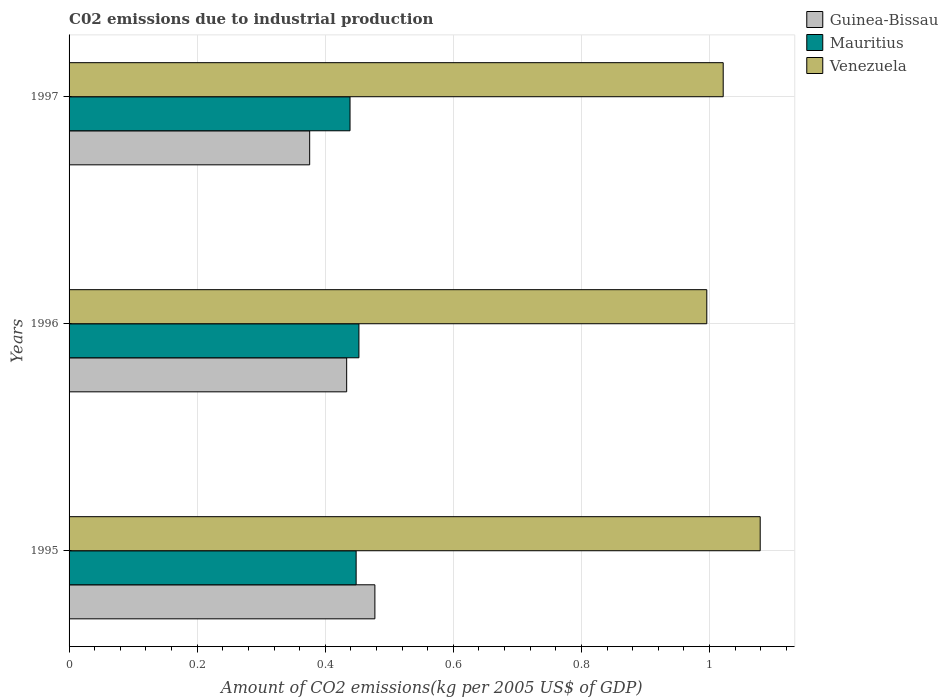Are the number of bars per tick equal to the number of legend labels?
Give a very brief answer. Yes. Are the number of bars on each tick of the Y-axis equal?
Your response must be concise. Yes. How many bars are there on the 2nd tick from the top?
Provide a short and direct response. 3. What is the label of the 1st group of bars from the top?
Ensure brevity in your answer.  1997. What is the amount of CO2 emitted due to industrial production in Venezuela in 1995?
Provide a short and direct response. 1.08. Across all years, what is the maximum amount of CO2 emitted due to industrial production in Guinea-Bissau?
Provide a succinct answer. 0.48. Across all years, what is the minimum amount of CO2 emitted due to industrial production in Venezuela?
Ensure brevity in your answer.  1. In which year was the amount of CO2 emitted due to industrial production in Guinea-Bissau minimum?
Provide a succinct answer. 1997. What is the total amount of CO2 emitted due to industrial production in Mauritius in the graph?
Provide a short and direct response. 1.34. What is the difference between the amount of CO2 emitted due to industrial production in Mauritius in 1996 and that in 1997?
Offer a very short reply. 0.01. What is the difference between the amount of CO2 emitted due to industrial production in Mauritius in 1997 and the amount of CO2 emitted due to industrial production in Guinea-Bissau in 1995?
Ensure brevity in your answer.  -0.04. What is the average amount of CO2 emitted due to industrial production in Venezuela per year?
Offer a very short reply. 1.03. In the year 1996, what is the difference between the amount of CO2 emitted due to industrial production in Guinea-Bissau and amount of CO2 emitted due to industrial production in Mauritius?
Offer a very short reply. -0.02. In how many years, is the amount of CO2 emitted due to industrial production in Guinea-Bissau greater than 0.7200000000000001 kg?
Provide a succinct answer. 0. What is the ratio of the amount of CO2 emitted due to industrial production in Venezuela in 1995 to that in 1996?
Your answer should be compact. 1.08. Is the amount of CO2 emitted due to industrial production in Venezuela in 1995 less than that in 1997?
Offer a terse response. No. What is the difference between the highest and the second highest amount of CO2 emitted due to industrial production in Mauritius?
Offer a very short reply. 0. What is the difference between the highest and the lowest amount of CO2 emitted due to industrial production in Mauritius?
Provide a short and direct response. 0.01. Is the sum of the amount of CO2 emitted due to industrial production in Venezuela in 1995 and 1997 greater than the maximum amount of CO2 emitted due to industrial production in Guinea-Bissau across all years?
Keep it short and to the point. Yes. What does the 1st bar from the top in 1995 represents?
Provide a short and direct response. Venezuela. What does the 1st bar from the bottom in 1997 represents?
Give a very brief answer. Guinea-Bissau. Is it the case that in every year, the sum of the amount of CO2 emitted due to industrial production in Guinea-Bissau and amount of CO2 emitted due to industrial production in Mauritius is greater than the amount of CO2 emitted due to industrial production in Venezuela?
Provide a succinct answer. No. Are all the bars in the graph horizontal?
Provide a short and direct response. Yes. How many years are there in the graph?
Ensure brevity in your answer.  3. What is the difference between two consecutive major ticks on the X-axis?
Give a very brief answer. 0.2. Are the values on the major ticks of X-axis written in scientific E-notation?
Offer a very short reply. No. Does the graph contain any zero values?
Your answer should be very brief. No. Does the graph contain grids?
Your response must be concise. Yes. Where does the legend appear in the graph?
Keep it short and to the point. Top right. How many legend labels are there?
Keep it short and to the point. 3. How are the legend labels stacked?
Make the answer very short. Vertical. What is the title of the graph?
Your answer should be compact. C02 emissions due to industrial production. What is the label or title of the X-axis?
Your response must be concise. Amount of CO2 emissions(kg per 2005 US$ of GDP). What is the Amount of CO2 emissions(kg per 2005 US$ of GDP) in Guinea-Bissau in 1995?
Your answer should be compact. 0.48. What is the Amount of CO2 emissions(kg per 2005 US$ of GDP) of Mauritius in 1995?
Provide a short and direct response. 0.45. What is the Amount of CO2 emissions(kg per 2005 US$ of GDP) in Venezuela in 1995?
Your response must be concise. 1.08. What is the Amount of CO2 emissions(kg per 2005 US$ of GDP) of Guinea-Bissau in 1996?
Your answer should be compact. 0.43. What is the Amount of CO2 emissions(kg per 2005 US$ of GDP) of Mauritius in 1996?
Provide a short and direct response. 0.45. What is the Amount of CO2 emissions(kg per 2005 US$ of GDP) in Venezuela in 1996?
Your response must be concise. 1. What is the Amount of CO2 emissions(kg per 2005 US$ of GDP) of Guinea-Bissau in 1997?
Keep it short and to the point. 0.38. What is the Amount of CO2 emissions(kg per 2005 US$ of GDP) of Mauritius in 1997?
Keep it short and to the point. 0.44. What is the Amount of CO2 emissions(kg per 2005 US$ of GDP) of Venezuela in 1997?
Provide a short and direct response. 1.02. Across all years, what is the maximum Amount of CO2 emissions(kg per 2005 US$ of GDP) in Guinea-Bissau?
Provide a short and direct response. 0.48. Across all years, what is the maximum Amount of CO2 emissions(kg per 2005 US$ of GDP) of Mauritius?
Give a very brief answer. 0.45. Across all years, what is the maximum Amount of CO2 emissions(kg per 2005 US$ of GDP) in Venezuela?
Provide a succinct answer. 1.08. Across all years, what is the minimum Amount of CO2 emissions(kg per 2005 US$ of GDP) of Guinea-Bissau?
Provide a short and direct response. 0.38. Across all years, what is the minimum Amount of CO2 emissions(kg per 2005 US$ of GDP) in Mauritius?
Offer a very short reply. 0.44. Across all years, what is the minimum Amount of CO2 emissions(kg per 2005 US$ of GDP) in Venezuela?
Ensure brevity in your answer.  1. What is the total Amount of CO2 emissions(kg per 2005 US$ of GDP) of Guinea-Bissau in the graph?
Your answer should be very brief. 1.29. What is the total Amount of CO2 emissions(kg per 2005 US$ of GDP) in Mauritius in the graph?
Your answer should be compact. 1.34. What is the total Amount of CO2 emissions(kg per 2005 US$ of GDP) in Venezuela in the graph?
Ensure brevity in your answer.  3.1. What is the difference between the Amount of CO2 emissions(kg per 2005 US$ of GDP) in Guinea-Bissau in 1995 and that in 1996?
Ensure brevity in your answer.  0.04. What is the difference between the Amount of CO2 emissions(kg per 2005 US$ of GDP) of Mauritius in 1995 and that in 1996?
Keep it short and to the point. -0. What is the difference between the Amount of CO2 emissions(kg per 2005 US$ of GDP) of Venezuela in 1995 and that in 1996?
Offer a very short reply. 0.08. What is the difference between the Amount of CO2 emissions(kg per 2005 US$ of GDP) in Guinea-Bissau in 1995 and that in 1997?
Keep it short and to the point. 0.1. What is the difference between the Amount of CO2 emissions(kg per 2005 US$ of GDP) of Mauritius in 1995 and that in 1997?
Provide a succinct answer. 0.01. What is the difference between the Amount of CO2 emissions(kg per 2005 US$ of GDP) of Venezuela in 1995 and that in 1997?
Provide a short and direct response. 0.06. What is the difference between the Amount of CO2 emissions(kg per 2005 US$ of GDP) in Guinea-Bissau in 1996 and that in 1997?
Provide a short and direct response. 0.06. What is the difference between the Amount of CO2 emissions(kg per 2005 US$ of GDP) in Mauritius in 1996 and that in 1997?
Provide a short and direct response. 0.01. What is the difference between the Amount of CO2 emissions(kg per 2005 US$ of GDP) of Venezuela in 1996 and that in 1997?
Ensure brevity in your answer.  -0.03. What is the difference between the Amount of CO2 emissions(kg per 2005 US$ of GDP) of Guinea-Bissau in 1995 and the Amount of CO2 emissions(kg per 2005 US$ of GDP) of Mauritius in 1996?
Provide a short and direct response. 0.02. What is the difference between the Amount of CO2 emissions(kg per 2005 US$ of GDP) of Guinea-Bissau in 1995 and the Amount of CO2 emissions(kg per 2005 US$ of GDP) of Venezuela in 1996?
Keep it short and to the point. -0.52. What is the difference between the Amount of CO2 emissions(kg per 2005 US$ of GDP) in Mauritius in 1995 and the Amount of CO2 emissions(kg per 2005 US$ of GDP) in Venezuela in 1996?
Keep it short and to the point. -0.55. What is the difference between the Amount of CO2 emissions(kg per 2005 US$ of GDP) of Guinea-Bissau in 1995 and the Amount of CO2 emissions(kg per 2005 US$ of GDP) of Mauritius in 1997?
Make the answer very short. 0.04. What is the difference between the Amount of CO2 emissions(kg per 2005 US$ of GDP) of Guinea-Bissau in 1995 and the Amount of CO2 emissions(kg per 2005 US$ of GDP) of Venezuela in 1997?
Give a very brief answer. -0.54. What is the difference between the Amount of CO2 emissions(kg per 2005 US$ of GDP) in Mauritius in 1995 and the Amount of CO2 emissions(kg per 2005 US$ of GDP) in Venezuela in 1997?
Give a very brief answer. -0.57. What is the difference between the Amount of CO2 emissions(kg per 2005 US$ of GDP) in Guinea-Bissau in 1996 and the Amount of CO2 emissions(kg per 2005 US$ of GDP) in Mauritius in 1997?
Provide a short and direct response. -0.01. What is the difference between the Amount of CO2 emissions(kg per 2005 US$ of GDP) of Guinea-Bissau in 1996 and the Amount of CO2 emissions(kg per 2005 US$ of GDP) of Venezuela in 1997?
Make the answer very short. -0.59. What is the difference between the Amount of CO2 emissions(kg per 2005 US$ of GDP) of Mauritius in 1996 and the Amount of CO2 emissions(kg per 2005 US$ of GDP) of Venezuela in 1997?
Provide a short and direct response. -0.57. What is the average Amount of CO2 emissions(kg per 2005 US$ of GDP) in Guinea-Bissau per year?
Give a very brief answer. 0.43. What is the average Amount of CO2 emissions(kg per 2005 US$ of GDP) in Mauritius per year?
Your answer should be compact. 0.45. What is the average Amount of CO2 emissions(kg per 2005 US$ of GDP) in Venezuela per year?
Ensure brevity in your answer.  1.03. In the year 1995, what is the difference between the Amount of CO2 emissions(kg per 2005 US$ of GDP) of Guinea-Bissau and Amount of CO2 emissions(kg per 2005 US$ of GDP) of Mauritius?
Offer a terse response. 0.03. In the year 1995, what is the difference between the Amount of CO2 emissions(kg per 2005 US$ of GDP) of Guinea-Bissau and Amount of CO2 emissions(kg per 2005 US$ of GDP) of Venezuela?
Your answer should be very brief. -0.6. In the year 1995, what is the difference between the Amount of CO2 emissions(kg per 2005 US$ of GDP) of Mauritius and Amount of CO2 emissions(kg per 2005 US$ of GDP) of Venezuela?
Your answer should be compact. -0.63. In the year 1996, what is the difference between the Amount of CO2 emissions(kg per 2005 US$ of GDP) in Guinea-Bissau and Amount of CO2 emissions(kg per 2005 US$ of GDP) in Mauritius?
Ensure brevity in your answer.  -0.02. In the year 1996, what is the difference between the Amount of CO2 emissions(kg per 2005 US$ of GDP) in Guinea-Bissau and Amount of CO2 emissions(kg per 2005 US$ of GDP) in Venezuela?
Give a very brief answer. -0.56. In the year 1996, what is the difference between the Amount of CO2 emissions(kg per 2005 US$ of GDP) in Mauritius and Amount of CO2 emissions(kg per 2005 US$ of GDP) in Venezuela?
Provide a succinct answer. -0.54. In the year 1997, what is the difference between the Amount of CO2 emissions(kg per 2005 US$ of GDP) of Guinea-Bissau and Amount of CO2 emissions(kg per 2005 US$ of GDP) of Mauritius?
Offer a terse response. -0.06. In the year 1997, what is the difference between the Amount of CO2 emissions(kg per 2005 US$ of GDP) in Guinea-Bissau and Amount of CO2 emissions(kg per 2005 US$ of GDP) in Venezuela?
Your answer should be compact. -0.65. In the year 1997, what is the difference between the Amount of CO2 emissions(kg per 2005 US$ of GDP) in Mauritius and Amount of CO2 emissions(kg per 2005 US$ of GDP) in Venezuela?
Give a very brief answer. -0.58. What is the ratio of the Amount of CO2 emissions(kg per 2005 US$ of GDP) of Guinea-Bissau in 1995 to that in 1996?
Make the answer very short. 1.1. What is the ratio of the Amount of CO2 emissions(kg per 2005 US$ of GDP) of Venezuela in 1995 to that in 1996?
Your answer should be very brief. 1.08. What is the ratio of the Amount of CO2 emissions(kg per 2005 US$ of GDP) of Guinea-Bissau in 1995 to that in 1997?
Your answer should be compact. 1.27. What is the ratio of the Amount of CO2 emissions(kg per 2005 US$ of GDP) in Mauritius in 1995 to that in 1997?
Provide a succinct answer. 1.02. What is the ratio of the Amount of CO2 emissions(kg per 2005 US$ of GDP) in Venezuela in 1995 to that in 1997?
Your answer should be very brief. 1.06. What is the ratio of the Amount of CO2 emissions(kg per 2005 US$ of GDP) of Guinea-Bissau in 1996 to that in 1997?
Your answer should be very brief. 1.15. What is the ratio of the Amount of CO2 emissions(kg per 2005 US$ of GDP) of Mauritius in 1996 to that in 1997?
Keep it short and to the point. 1.03. What is the ratio of the Amount of CO2 emissions(kg per 2005 US$ of GDP) of Venezuela in 1996 to that in 1997?
Keep it short and to the point. 0.97. What is the difference between the highest and the second highest Amount of CO2 emissions(kg per 2005 US$ of GDP) in Guinea-Bissau?
Ensure brevity in your answer.  0.04. What is the difference between the highest and the second highest Amount of CO2 emissions(kg per 2005 US$ of GDP) of Mauritius?
Your answer should be compact. 0. What is the difference between the highest and the second highest Amount of CO2 emissions(kg per 2005 US$ of GDP) of Venezuela?
Give a very brief answer. 0.06. What is the difference between the highest and the lowest Amount of CO2 emissions(kg per 2005 US$ of GDP) in Guinea-Bissau?
Keep it short and to the point. 0.1. What is the difference between the highest and the lowest Amount of CO2 emissions(kg per 2005 US$ of GDP) of Mauritius?
Your answer should be compact. 0.01. What is the difference between the highest and the lowest Amount of CO2 emissions(kg per 2005 US$ of GDP) in Venezuela?
Your answer should be compact. 0.08. 